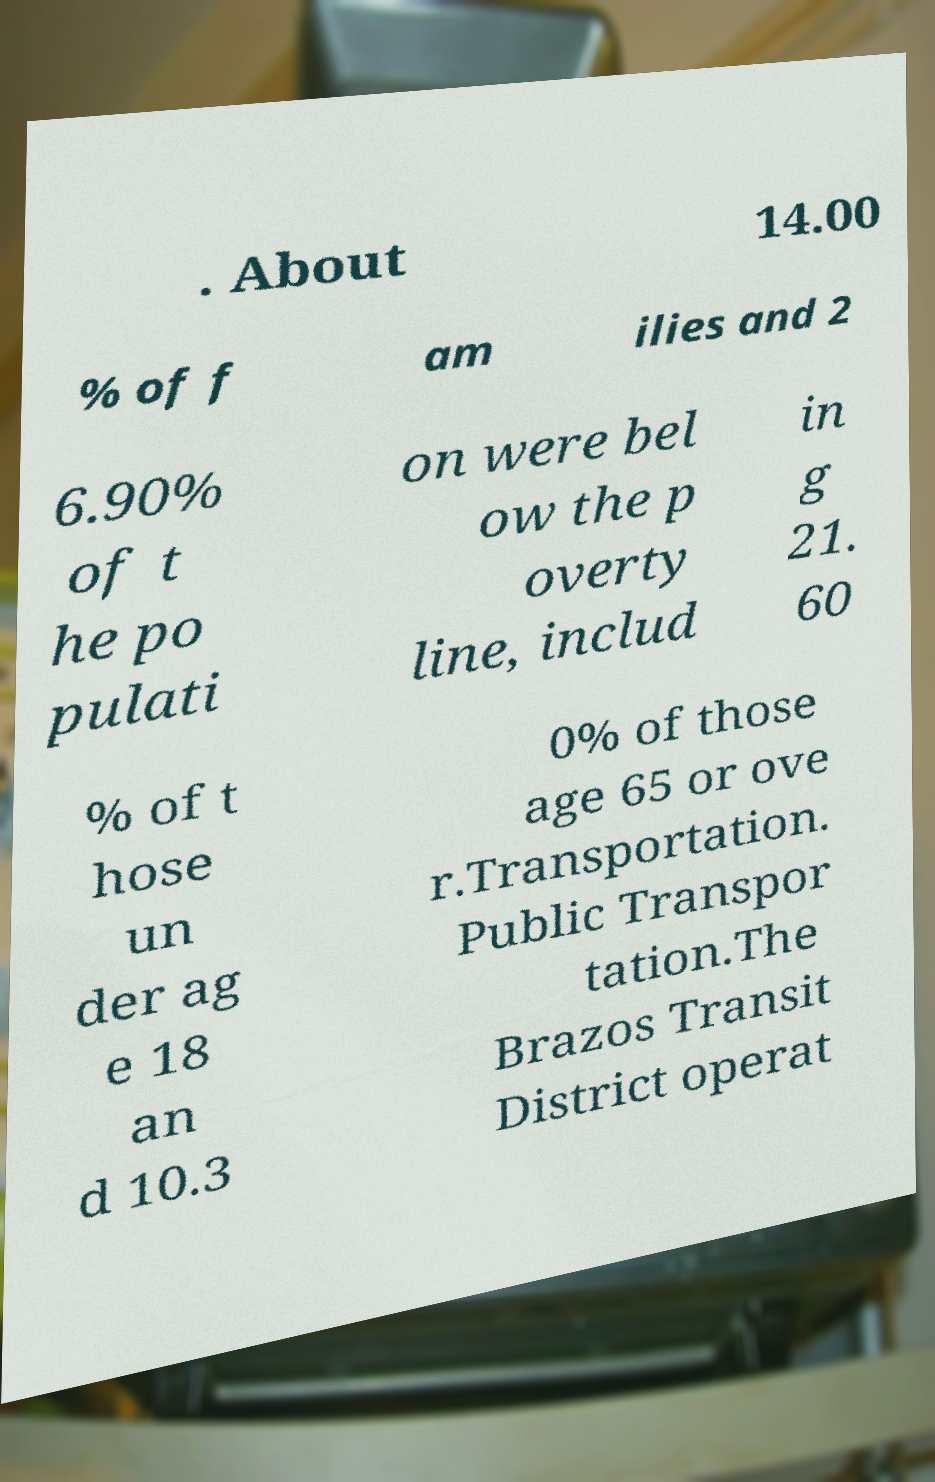Can you accurately transcribe the text from the provided image for me? . About 14.00 % of f am ilies and 2 6.90% of t he po pulati on were bel ow the p overty line, includ in g 21. 60 % of t hose un der ag e 18 an d 10.3 0% of those age 65 or ove r.Transportation. Public Transpor tation.The Brazos Transit District operat 